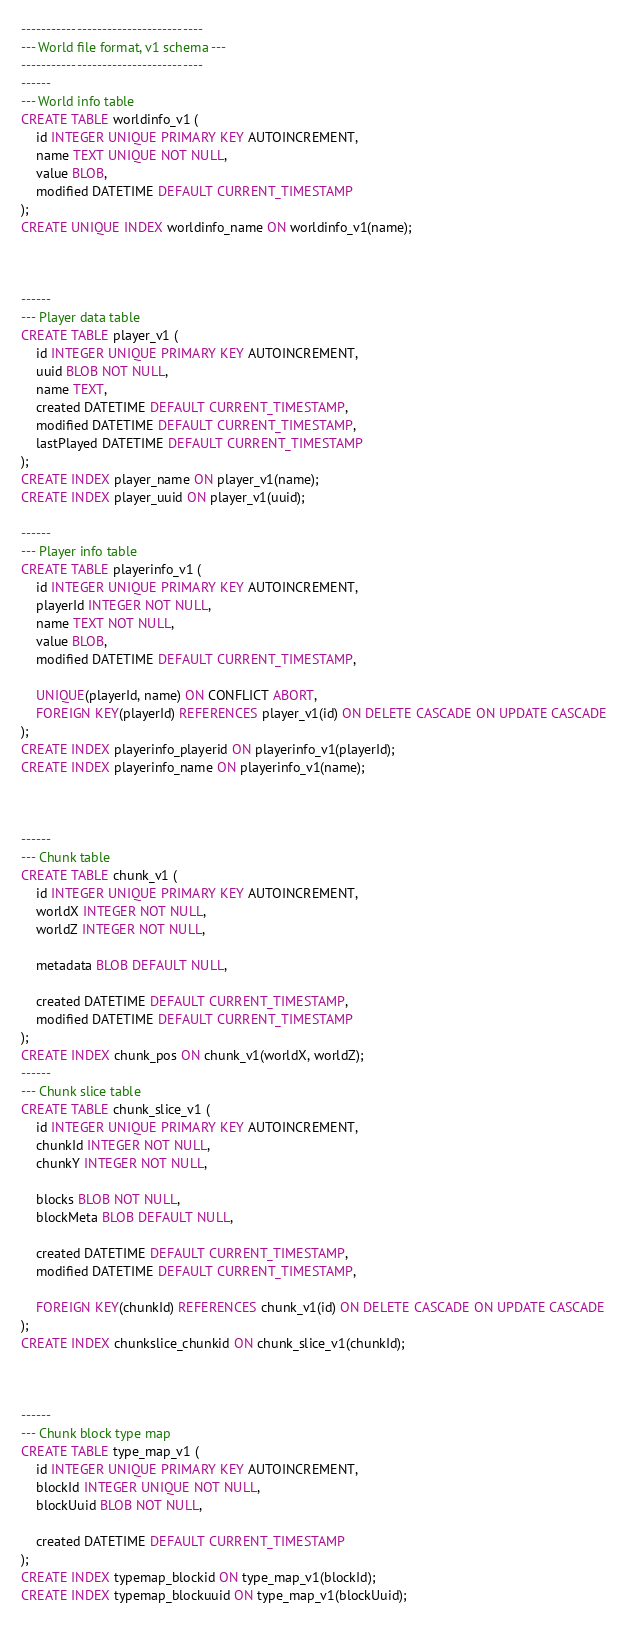<code> <loc_0><loc_0><loc_500><loc_500><_SQL_>------------------------------------
--- World file format, v1 schema ---
------------------------------------
------
--- World info table
CREATE TABLE worldinfo_v1 (
    id INTEGER UNIQUE PRIMARY KEY AUTOINCREMENT,
    name TEXT UNIQUE NOT NULL,
    value BLOB,
    modified DATETIME DEFAULT CURRENT_TIMESTAMP
);
CREATE UNIQUE INDEX worldinfo_name ON worldinfo_v1(name);



------
--- Player data table
CREATE TABLE player_v1 (
    id INTEGER UNIQUE PRIMARY KEY AUTOINCREMENT,
    uuid BLOB NOT NULL,
    name TEXT,
    created DATETIME DEFAULT CURRENT_TIMESTAMP,
    modified DATETIME DEFAULT CURRENT_TIMESTAMP,
    lastPlayed DATETIME DEFAULT CURRENT_TIMESTAMP
);
CREATE INDEX player_name ON player_v1(name);
CREATE INDEX player_uuid ON player_v1(uuid);

------
--- Player info table
CREATE TABLE playerinfo_v1 (
    id INTEGER UNIQUE PRIMARY KEY AUTOINCREMENT,
    playerId INTEGER NOT NULL,
    name TEXT NOT NULL,
    value BLOB,
    modified DATETIME DEFAULT CURRENT_TIMESTAMP,

    UNIQUE(playerId, name) ON CONFLICT ABORT,
    FOREIGN KEY(playerId) REFERENCES player_v1(id) ON DELETE CASCADE ON UPDATE CASCADE
);
CREATE INDEX playerinfo_playerid ON playerinfo_v1(playerId);
CREATE INDEX playerinfo_name ON playerinfo_v1(name);



------
--- Chunk table
CREATE TABLE chunk_v1 (
    id INTEGER UNIQUE PRIMARY KEY AUTOINCREMENT,
    worldX INTEGER NOT NULL,
    worldZ INTEGER NOT NULL,

    metadata BLOB DEFAULT NULL,

    created DATETIME DEFAULT CURRENT_TIMESTAMP,
    modified DATETIME DEFAULT CURRENT_TIMESTAMP
);
CREATE INDEX chunk_pos ON chunk_v1(worldX, worldZ);
------
--- Chunk slice table
CREATE TABLE chunk_slice_v1 (
    id INTEGER UNIQUE PRIMARY KEY AUTOINCREMENT,
    chunkId INTEGER NOT NULL,
    chunkY INTEGER NOT NULL,
    
    blocks BLOB NOT NULL,
    blockMeta BLOB DEFAULT NULL,

    created DATETIME DEFAULT CURRENT_TIMESTAMP,
    modified DATETIME DEFAULT CURRENT_TIMESTAMP,

    FOREIGN KEY(chunkId) REFERENCES chunk_v1(id) ON DELETE CASCADE ON UPDATE CASCADE
);
CREATE INDEX chunkslice_chunkid ON chunk_slice_v1(chunkId);



------
--- Chunk block type map
CREATE TABLE type_map_v1 (
    id INTEGER UNIQUE PRIMARY KEY AUTOINCREMENT,
    blockId INTEGER UNIQUE NOT NULL,
    blockUuid BLOB NOT NULL,

    created DATETIME DEFAULT CURRENT_TIMESTAMP
);
CREATE INDEX typemap_blockid ON type_map_v1(blockId);
CREATE INDEX typemap_blockuuid ON type_map_v1(blockUuid);
</code> 